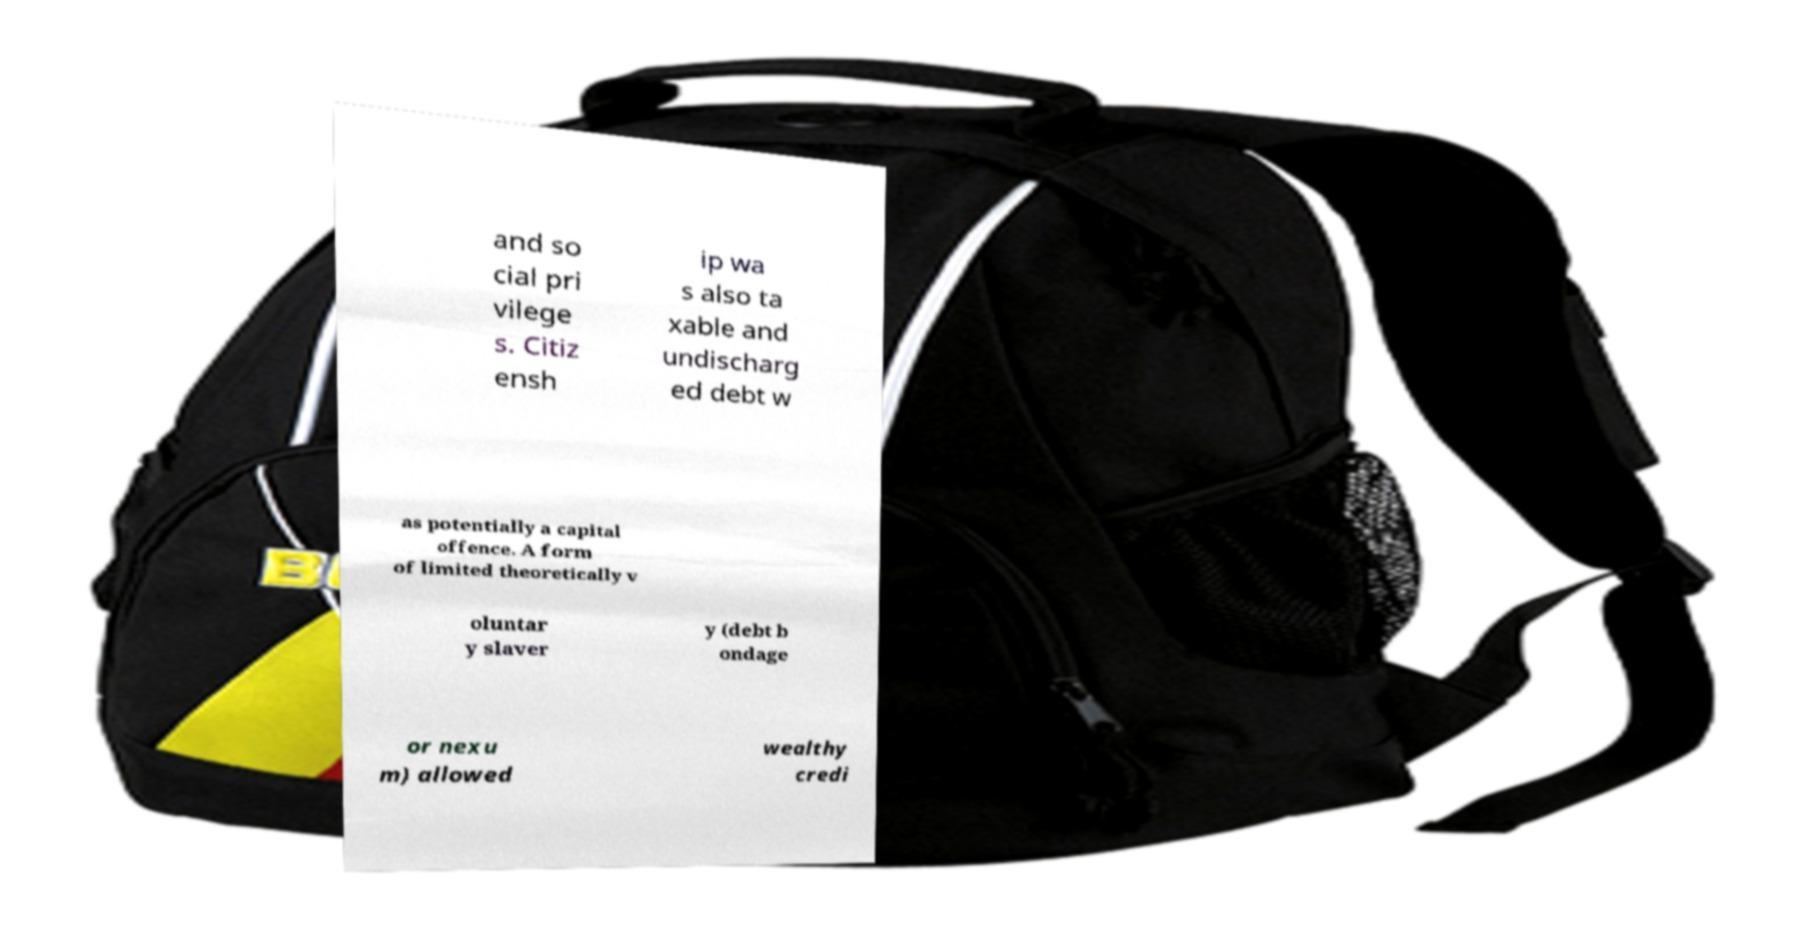Could you extract and type out the text from this image? and so cial pri vilege s. Citiz ensh ip wa s also ta xable and undischarg ed debt w as potentially a capital offence. A form of limited theoretically v oluntar y slaver y (debt b ondage or nexu m) allowed wealthy credi 